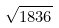Convert formula to latex. <formula><loc_0><loc_0><loc_500><loc_500>\sqrt { 1 8 3 6 }</formula> 